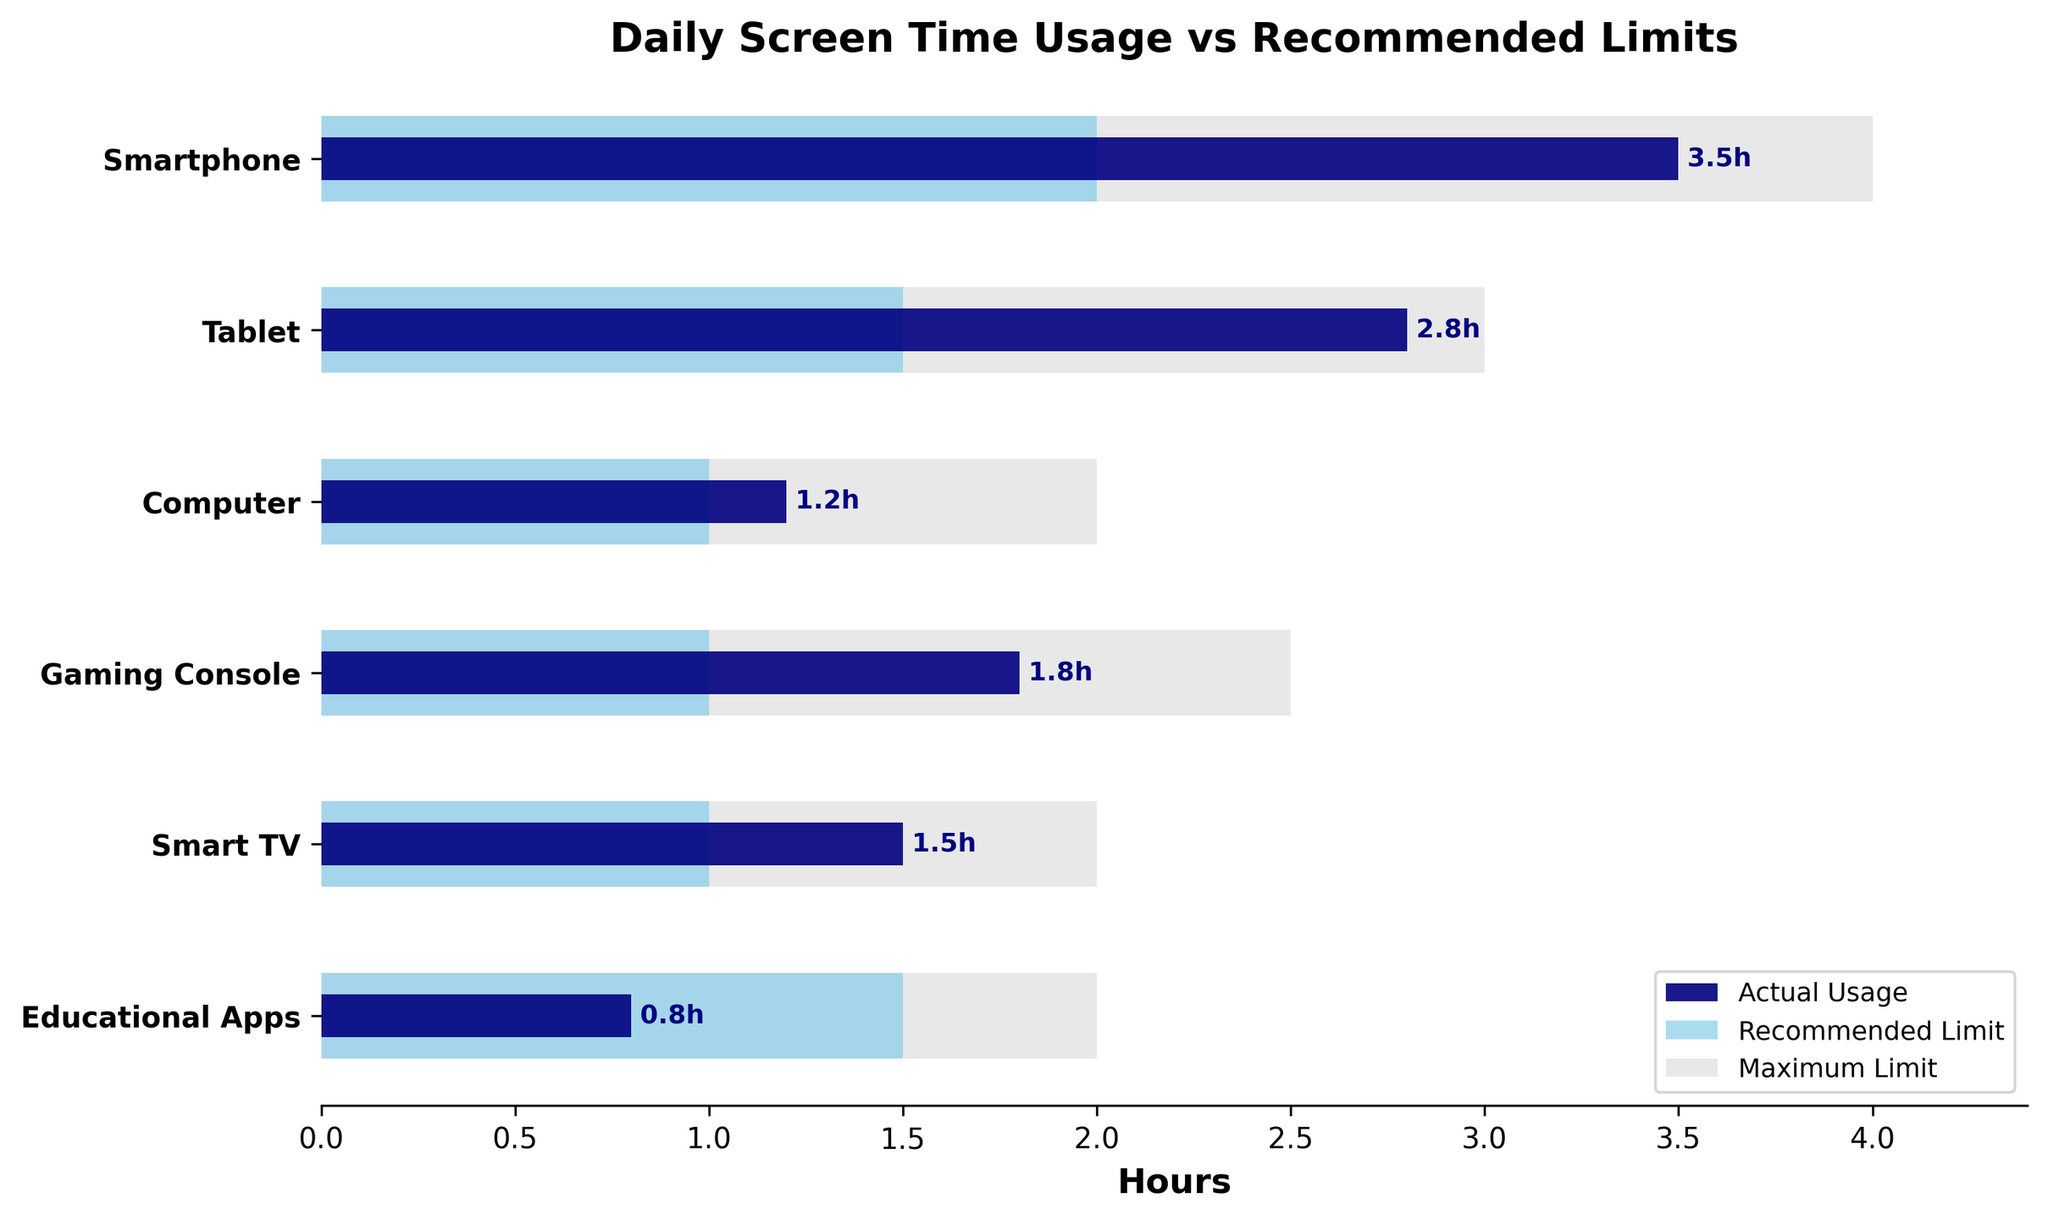What is the title of the figure? The title of the figure is displayed at the top and provides a summary of what the chart is about.
Answer: Daily Screen Time Usage vs Recommended Limits How many devices are compared in the chart? The number of devices can be counted on the y-axis, where each device's name is listed.
Answer: 6 Which device has the highest actual usage? The highest actual usage is seen by looking at the darkest bars (representing actual usage) and comparing their lengths.
Answer: Smartphone What is the difference between the actual usage and recommended limit for the Gaming Console? To find this, look at the lengths of the bars for the Gaming Console, then subtract the recommended limit from the actual usage. 1.8 (actual) - 1 (recommended) = 0.8
Answer: 0.8 hours Compare the actual usage of Smartphones to Tablets. Which one is greater and by how much? Compare the length of the darkest bar for both the Smartphone and Tablet, then subtract the shorter bar’s value from the longer one. 3.5 (Smartphone) - 2.8 (Tablet) = 0.7
Answer: Smartphone by 0.7 hours Which device has an actual usage that is within the recommended limit? Look for devices where the length of the darkest bar (actual usage) is less than or equal to the light blue bar (recommended limit).
Answer: Educational Apps, Computer, Smart TV Is there any device where the actual usage exceeds the maximum limit? Compare the actual usage (darkest bars) with the max limit (light gray bars).
Answer: No What is the average recommended limit across all devices? Add up all the recommended limits (2, 1.5, 1, 1, 1.5) and divide by the number of devices. (2 + 1.5 + 1 + 1 + 1.5 + 1.5) / 6 = 1.25
Answer: 1.25 hours Which device has the smallest difference between actual usage and maximum limit? Calculate the difference between actual usage and max limit for each device, then find the smallest difference. Smartphone: 4 - 3.5 = 0.5 Tablet: 3 - 2.8 = 0.2 Computer: 2 - 1.2 = 0.8 Gaming Console: 2.5 - 1.8 = 0.7 Smart TV: 2 - 1.5 = 0.5 Educational Apps: 2 - 0.8 = 1.2
Answer: Tablet (0.2 hours) 